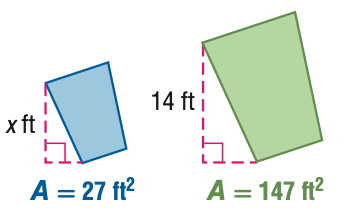Question: For the pair of similar figures, use the given areas to find the scale factor of the blue to the green figure.
Choices:
A. \frac { 9 } { 49 }
B. \frac { 3 } { 7 }
C. \frac { 7 } { 3 }
D. \frac { 49 } { 9 }
Answer with the letter. Answer: B 